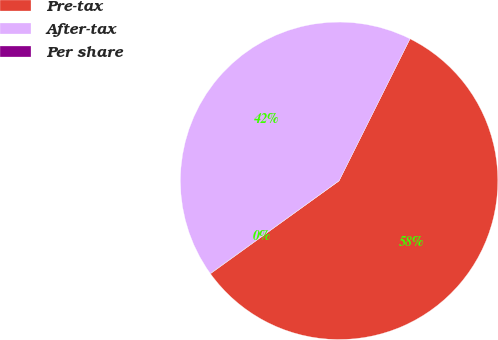<chart> <loc_0><loc_0><loc_500><loc_500><pie_chart><fcel>Pre-tax<fcel>After-tax<fcel>Per share<nl><fcel>57.68%<fcel>42.3%<fcel>0.03%<nl></chart> 